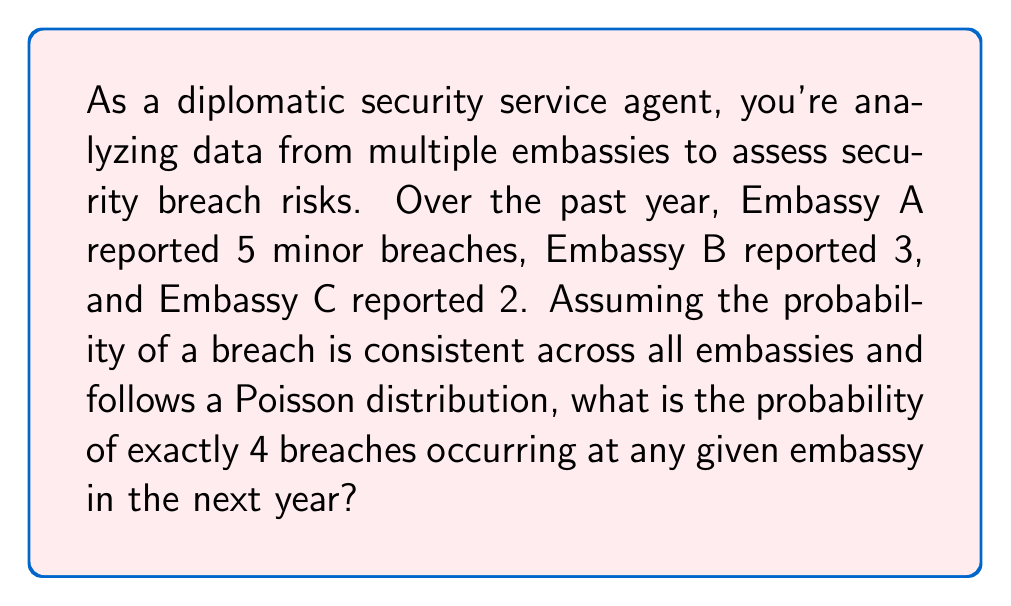Could you help me with this problem? To solve this problem, we'll use the Poisson distribution, which is suitable for modeling rare events over a fixed interval. Let's approach this step-by-step:

1) First, we need to calculate the average (λ) number of breaches per embassy per year:

   Total breaches = 5 + 3 + 2 = 10
   Number of embassies = 3
   λ = 10 / 3 ≈ 3.33 breaches per embassy per year

2) The Poisson probability mass function is:

   $$P(X = k) = \frac{e^{-λ} λ^k}{k!}$$

   Where:
   - e is Euler's number (≈ 2.71828)
   - λ is the average rate of occurrence
   - k is the number of occurrences we're interested in (4 in this case)

3) Let's substitute our values:

   $$P(X = 4) = \frac{e^{-3.33} (3.33)^4}{4!}$$

4) Now let's calculate step-by-step:

   $$P(X = 4) = \frac{0.03581 * 122.46}{24}$$

   $$P(X = 4) = \frac{4.3873}{24}$$

   $$P(X = 4) = 0.1828$$

5) Converting to a percentage:

   0.1828 * 100 = 18.28%

Therefore, the probability of exactly 4 breaches occurring at any given embassy in the next year is approximately 18.28%.
Answer: 18.28% 